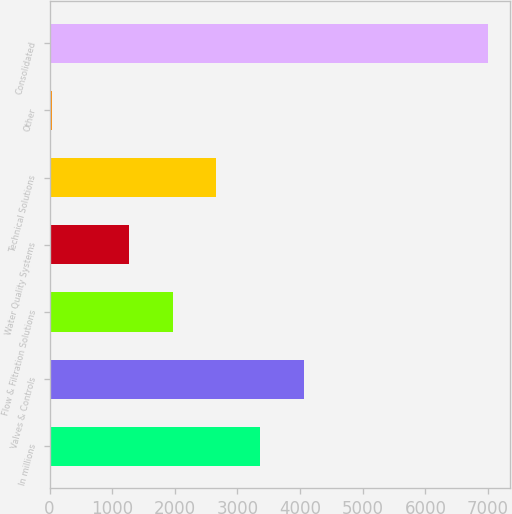Convert chart to OTSL. <chart><loc_0><loc_0><loc_500><loc_500><bar_chart><fcel>In millions<fcel>Valves & Controls<fcel>Flow & Filtration Solutions<fcel>Water Quality Systems<fcel>Technical Solutions<fcel>Other<fcel>Consolidated<nl><fcel>3358.26<fcel>4054.58<fcel>1965.62<fcel>1269.3<fcel>2661.94<fcel>36.5<fcel>6999.7<nl></chart> 